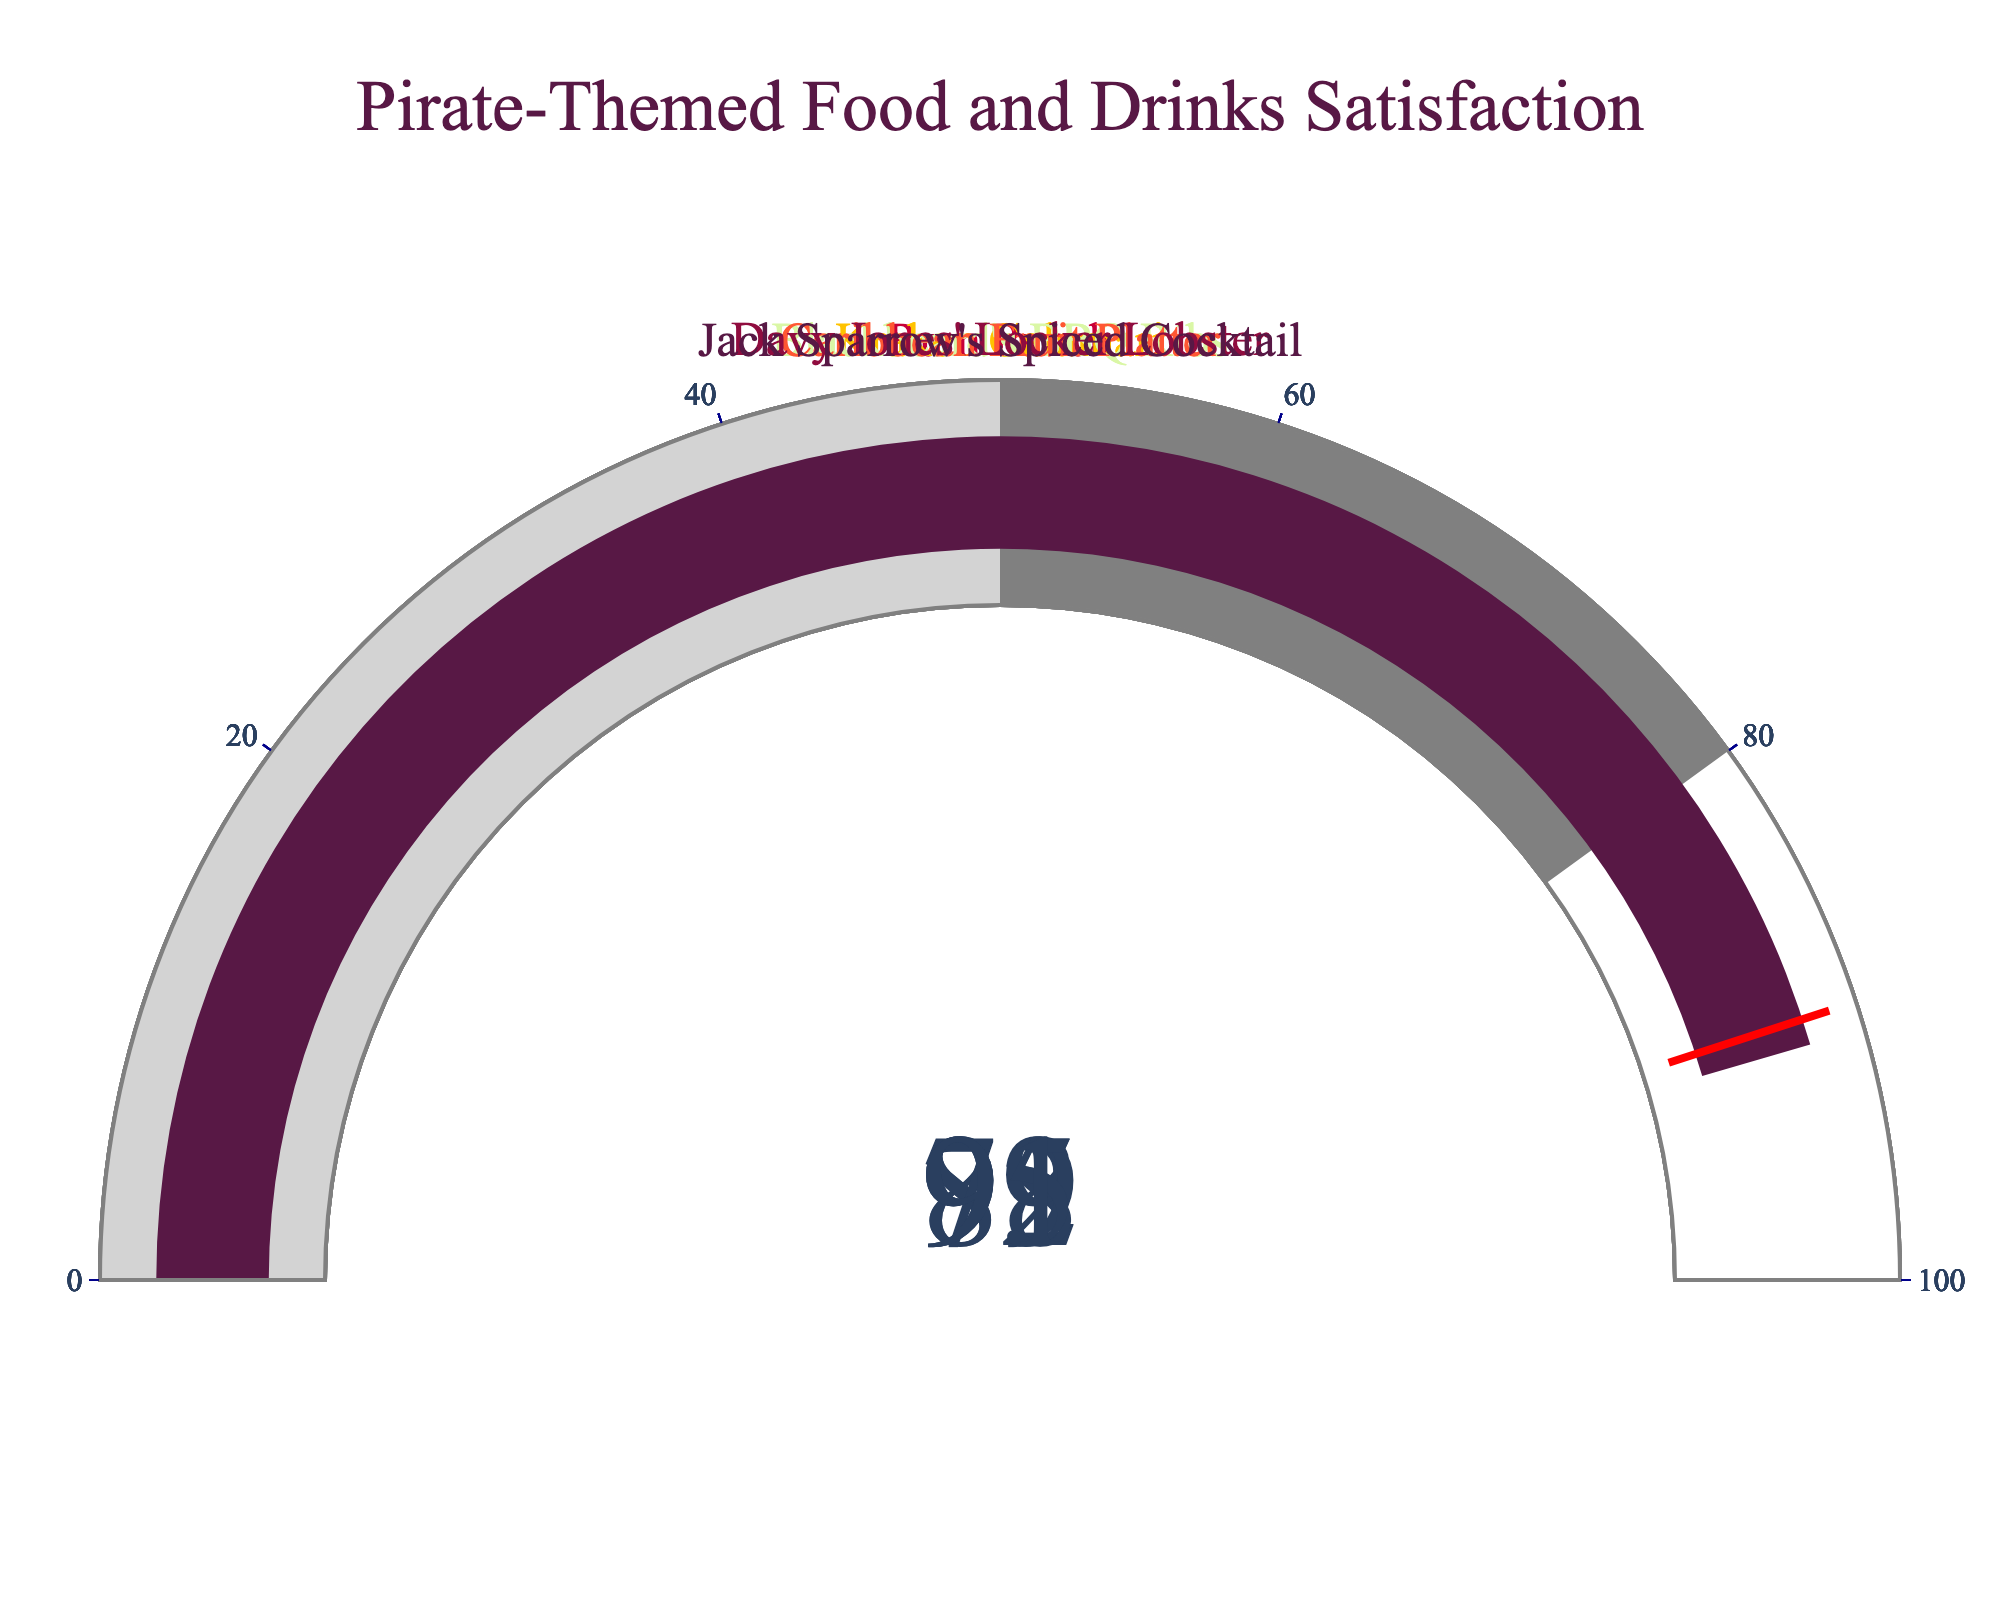what is the highest rating among the food and drinks? The figure has multiple gauges, each showing a rating for different items. The highest value displayed is 95 for "Davy Jones' Locker Lobster".
Answer: 95 what is the lowest rating among the food and drinks? The lowest value displayed on the gauges is 79, which is for the "Caribbean Fruit Platter".
Answer: 79 which item has the second highest rating? Davy Jones' Locker Lobster has the highest rating at 95. The second highest rating is 92, which belongs to "Kraken Calamari".
Answer: Kraken Calamari what's the average rating of all the items? To find the average, sum up all the ratings (85 + 92 + 88 + 79 + 95 + 91) = 530, then divide by the number of items (6): 530 / 6
Answer: 88.33 how many items have a rating above 90? The items with ratings above 90 are: "Kraken Calamari" (92), "Davy Jones' Locker Lobster" (95), and "Jack Sparrow's Spiced Cocktail" (91). Therefore, there are three items in total.
Answer: 3 which item has the smallest difference in rating compared to the "Kraken Calamari"? The rating of "Kraken Calamari" is 92. The differences in rating between other items and "Kraken Calamari" are as follows: "Rum Punch" (85) = 7, "Blackbeard's BBQ Ribs" (88) = 4, "Caribbean Fruit Platter" (79) = 13, "Davy Jones' Locker Lobster" (95) = 3, "Jack Sparrow's Spiced Cocktail" (91) = 1. The smallest difference is 1, which comes from "Jack Sparrow's Spiced Cocktail".
Answer: Jack Sparrow's Spiced Cocktail which color is used for the gauge of the "Blackbeard's BBQ Ribs"? Each gauge is associated with a specific color. The color for "Blackbeard's BBQ Ribs" is one of the predefined colors in the sequence, specifically the 3rd color in the list. However, without seeing the exact figure, it's assumed from a typical color order, it's likely a form of light brown.
Answer: a form of light brown are there any items with a rating within the 50-80 range? The figure uses a step color to indicate the range from 50 to 80. The "Caribbean Fruit Platter" has a rating of 79, which falls within this range.
Answer: Yes how many items have ratings that fall within the last step colored in gray? The last step colored in gray includes the ranges of 50 to 80. The "Caribbean Fruit Platter" with the rating of 79 falls within this range. Thus, only one item falls within this range.
Answer: 1 what is the median rating of the items? The ratings sorted in increasing order are 79, 85, 88, 91, 92, 95. The median is the average of the two middle values, (88 + 91) / 2 = 89.5
Answer: 89.5 